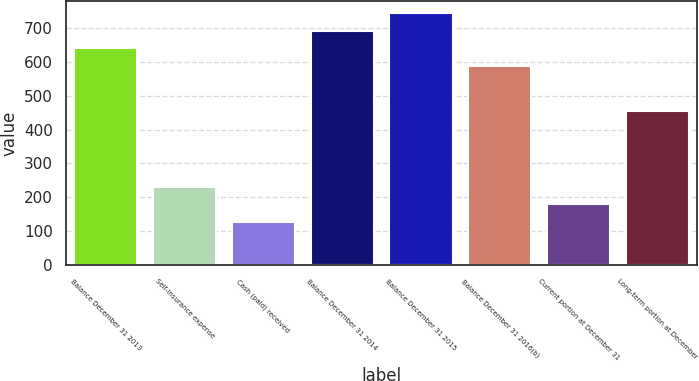Convert chart to OTSL. <chart><loc_0><loc_0><loc_500><loc_500><bar_chart><fcel>Balance December 31 2013<fcel>Self-insurance expense<fcel>Cash (paid) received<fcel>Balance December 31 2014<fcel>Balance December 31 2015<fcel>Balance December 31 2016(b)<fcel>Current portion at December 31<fcel>Long-term portion at December<nl><fcel>639.5<fcel>231<fcel>128<fcel>691<fcel>742.5<fcel>588<fcel>179.5<fcel>455<nl></chart> 